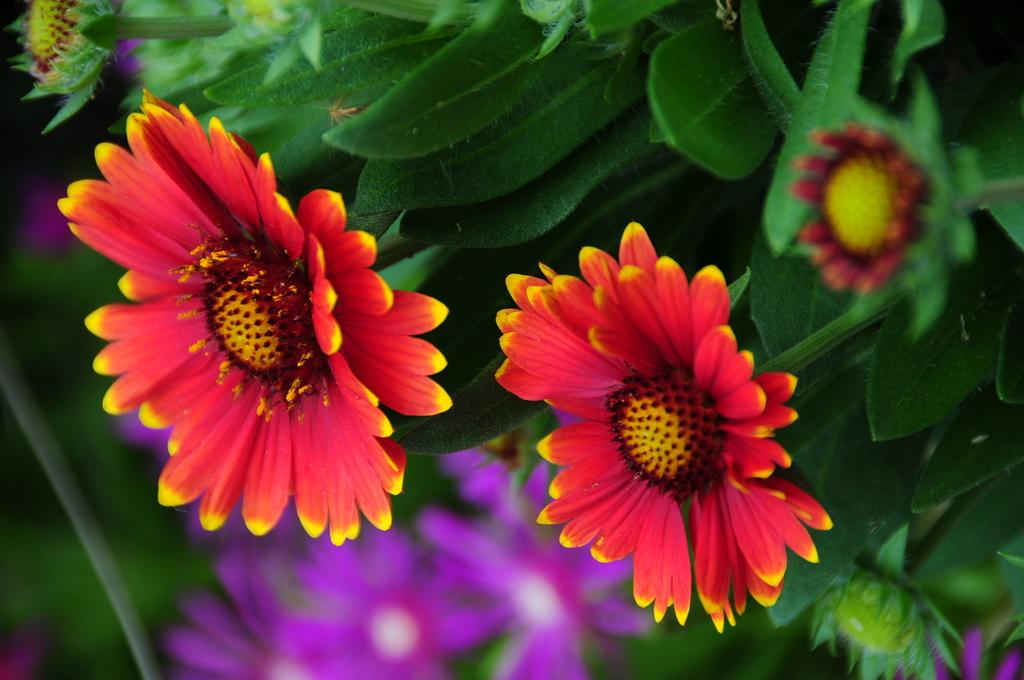What type of flowers are present in the image? There are sunflowers in the image. What color are the leaves in the image? The leaves in the image are green. Are there any sunflowers with a different color in the image? Yes, there are purple color sunflowers at the bottom of the image. What type of food is being prepared in the image? There is no food preparation visible in the image; it features sunflowers and green leaves. What type of jewel can be seen on the sunflower in the image? There are no jewels present on the sunflowers in the image. 